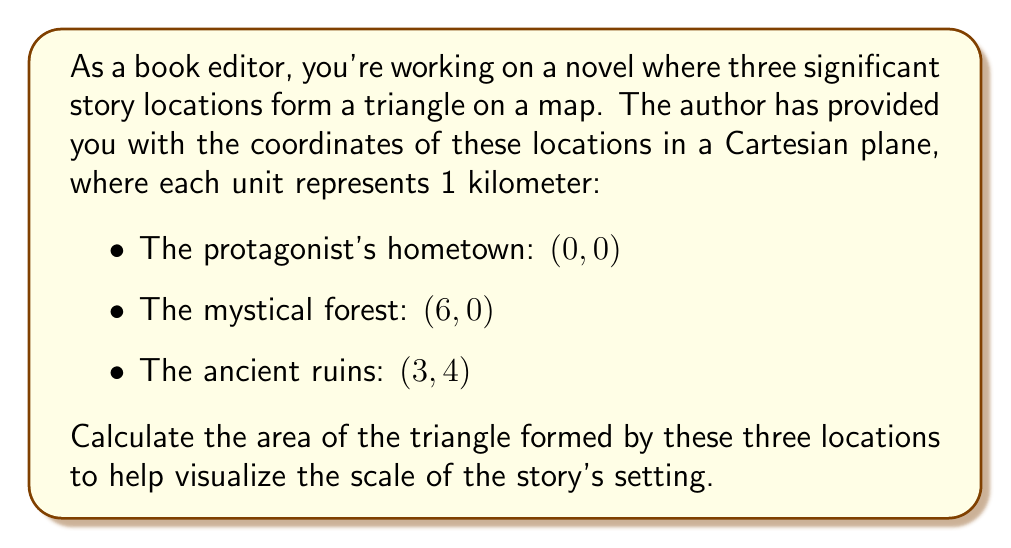Could you help me with this problem? To calculate the area of a triangle given the coordinates of its vertices, we can use the formula:

$$ \text{Area} = \frac{1}{2}|x_1(y_2 - y_3) + x_2(y_3 - y_1) + x_3(y_1 - y_2)| $$

Where $(x_1, y_1)$, $(x_2, y_2)$, and $(x_3, y_3)$ are the coordinates of the three vertices.

Let's assign our coordinates:
$(x_1, y_1) = (0, 0)$ (hometown)
$(x_2, y_2) = (6, 0)$ (mystical forest)
$(x_3, y_3) = (3, 4)$ (ancient ruins)

Now, let's substitute these values into the formula:

$$ \begin{align*}
\text{Area} &= \frac{1}{2}|0(0 - 4) + 6(4 - 0) + 3(0 - 0)| \\
&= \frac{1}{2}|0 + 24 + 0| \\
&= \frac{1}{2}(24) \\
&= 12
\end{align*} $$

[asy]
unitsize(1cm);
draw((0,0)--(6,0)--(3,4)--cycle);
dot((0,0)); dot((6,0)); dot((3,4));
label("Hometown (0,0)", (0,0), SW);
label("Mystical Forest (6,0)", (6,0), SE);
label("Ancient Ruins (3,4)", (3,4), N);
[/asy]

The area of the triangle is 12 square units. Since each unit represents 1 kilometer, the area of the triangle formed by the three story locations is 12 square kilometers.
Answer: The area of the triangle formed by the three significant story locations is 12 square kilometers. 